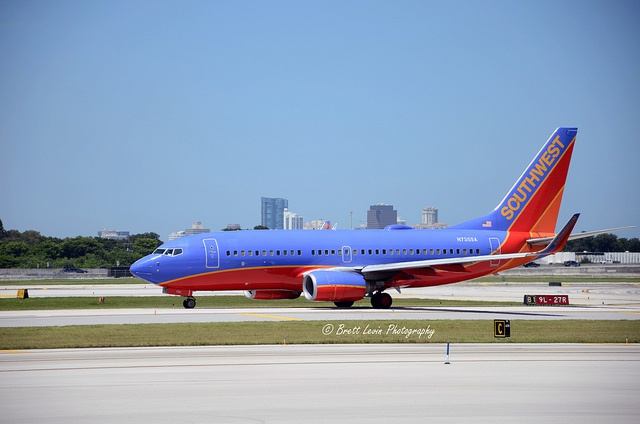Describe the objects in this image and their specific colors. I can see a airplane in gray, lightblue, brown, blue, and maroon tones in this image. 